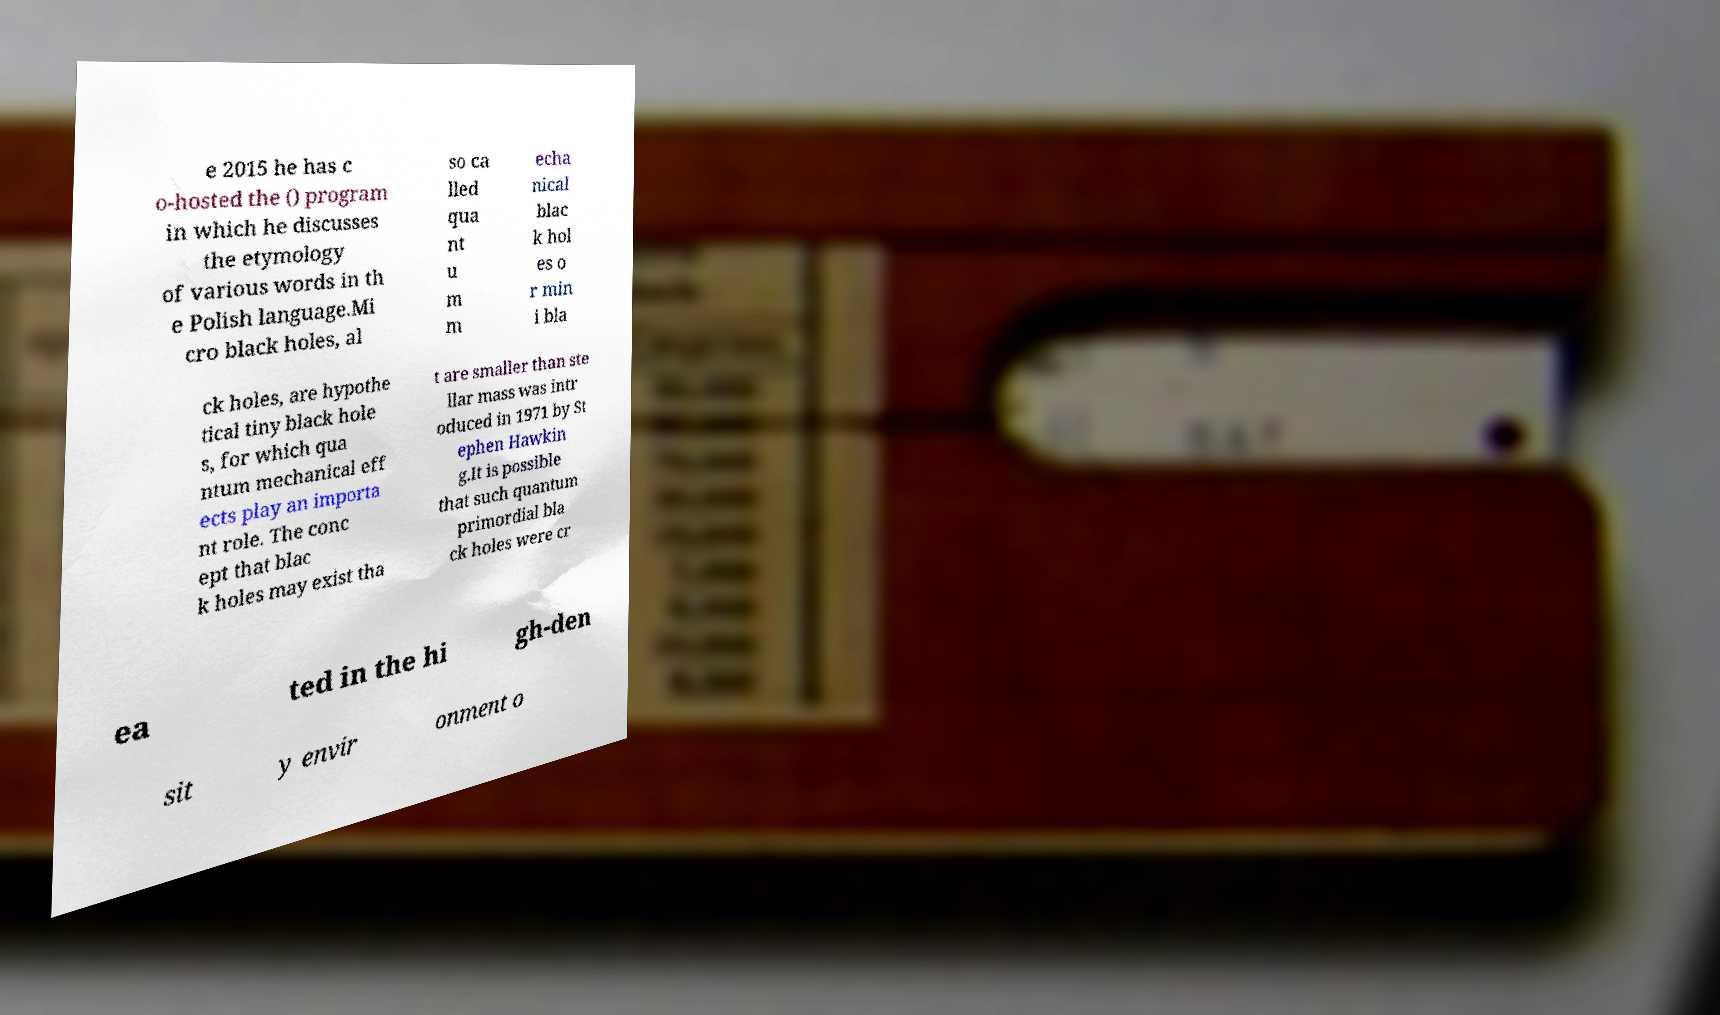Please identify and transcribe the text found in this image. e 2015 he has c o-hosted the () program in which he discusses the etymology of various words in th e Polish language.Mi cro black holes, al so ca lled qua nt u m m echa nical blac k hol es o r min i bla ck holes, are hypothe tical tiny black hole s, for which qua ntum mechanical eff ects play an importa nt role. The conc ept that blac k holes may exist tha t are smaller than ste llar mass was intr oduced in 1971 by St ephen Hawkin g.It is possible that such quantum primordial bla ck holes were cr ea ted in the hi gh-den sit y envir onment o 